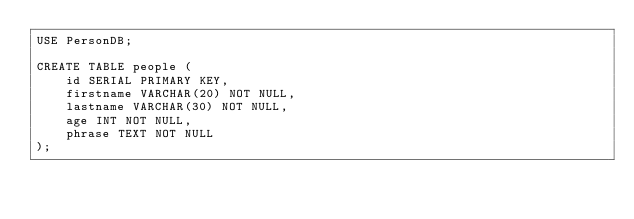Convert code to text. <code><loc_0><loc_0><loc_500><loc_500><_SQL_>USE PersonDB;

CREATE TABLE people (
    id SERIAL PRIMARY KEY,
    firstname VARCHAR(20) NOT NULL,
    lastname VARCHAR(30) NOT NULL,
    age INT NOT NULL,
    phrase TEXT NOT NULL
);</code> 